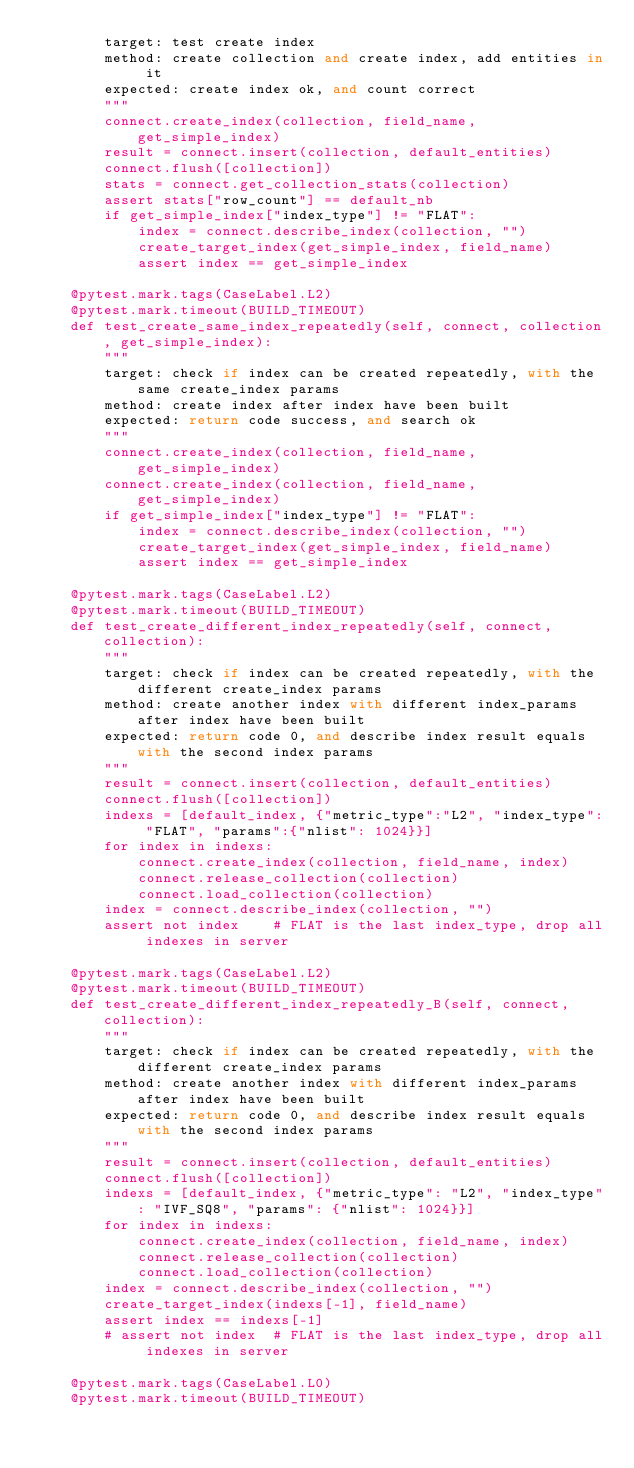<code> <loc_0><loc_0><loc_500><loc_500><_Python_>        target: test create index
        method: create collection and create index, add entities in it
        expected: create index ok, and count correct
        """
        connect.create_index(collection, field_name, get_simple_index)
        result = connect.insert(collection, default_entities)
        connect.flush([collection])
        stats = connect.get_collection_stats(collection)
        assert stats["row_count"] == default_nb
        if get_simple_index["index_type"] != "FLAT":
            index = connect.describe_index(collection, "")
            create_target_index(get_simple_index, field_name)
            assert index == get_simple_index

    @pytest.mark.tags(CaseLabel.L2)
    @pytest.mark.timeout(BUILD_TIMEOUT)
    def test_create_same_index_repeatedly(self, connect, collection, get_simple_index):
        """
        target: check if index can be created repeatedly, with the same create_index params
        method: create index after index have been built
        expected: return code success, and search ok
        """
        connect.create_index(collection, field_name, get_simple_index)
        connect.create_index(collection, field_name, get_simple_index)
        if get_simple_index["index_type"] != "FLAT":
            index = connect.describe_index(collection, "")
            create_target_index(get_simple_index, field_name)
            assert index == get_simple_index

    @pytest.mark.tags(CaseLabel.L2)
    @pytest.mark.timeout(BUILD_TIMEOUT)
    def test_create_different_index_repeatedly(self, connect, collection):
        """
        target: check if index can be created repeatedly, with the different create_index params
        method: create another index with different index_params after index have been built
        expected: return code 0, and describe index result equals with the second index params
        """
        result = connect.insert(collection, default_entities)
        connect.flush([collection])
        indexs = [default_index, {"metric_type":"L2", "index_type": "FLAT", "params":{"nlist": 1024}}]
        for index in indexs:
            connect.create_index(collection, field_name, index)
            connect.release_collection(collection)
            connect.load_collection(collection)
        index = connect.describe_index(collection, "")
        assert not index    # FLAT is the last index_type, drop all indexes in server

    @pytest.mark.tags(CaseLabel.L2)
    @pytest.mark.timeout(BUILD_TIMEOUT)
    def test_create_different_index_repeatedly_B(self, connect, collection):
        """
        target: check if index can be created repeatedly, with the different create_index params
        method: create another index with different index_params after index have been built
        expected: return code 0, and describe index result equals with the second index params
        """
        result = connect.insert(collection, default_entities)
        connect.flush([collection])
        indexs = [default_index, {"metric_type": "L2", "index_type": "IVF_SQ8", "params": {"nlist": 1024}}]
        for index in indexs:
            connect.create_index(collection, field_name, index)
            connect.release_collection(collection)
            connect.load_collection(collection)
        index = connect.describe_index(collection, "")
        create_target_index(indexs[-1], field_name)
        assert index == indexs[-1]
        # assert not index  # FLAT is the last index_type, drop all indexes in server

    @pytest.mark.tags(CaseLabel.L0)
    @pytest.mark.timeout(BUILD_TIMEOUT)</code> 